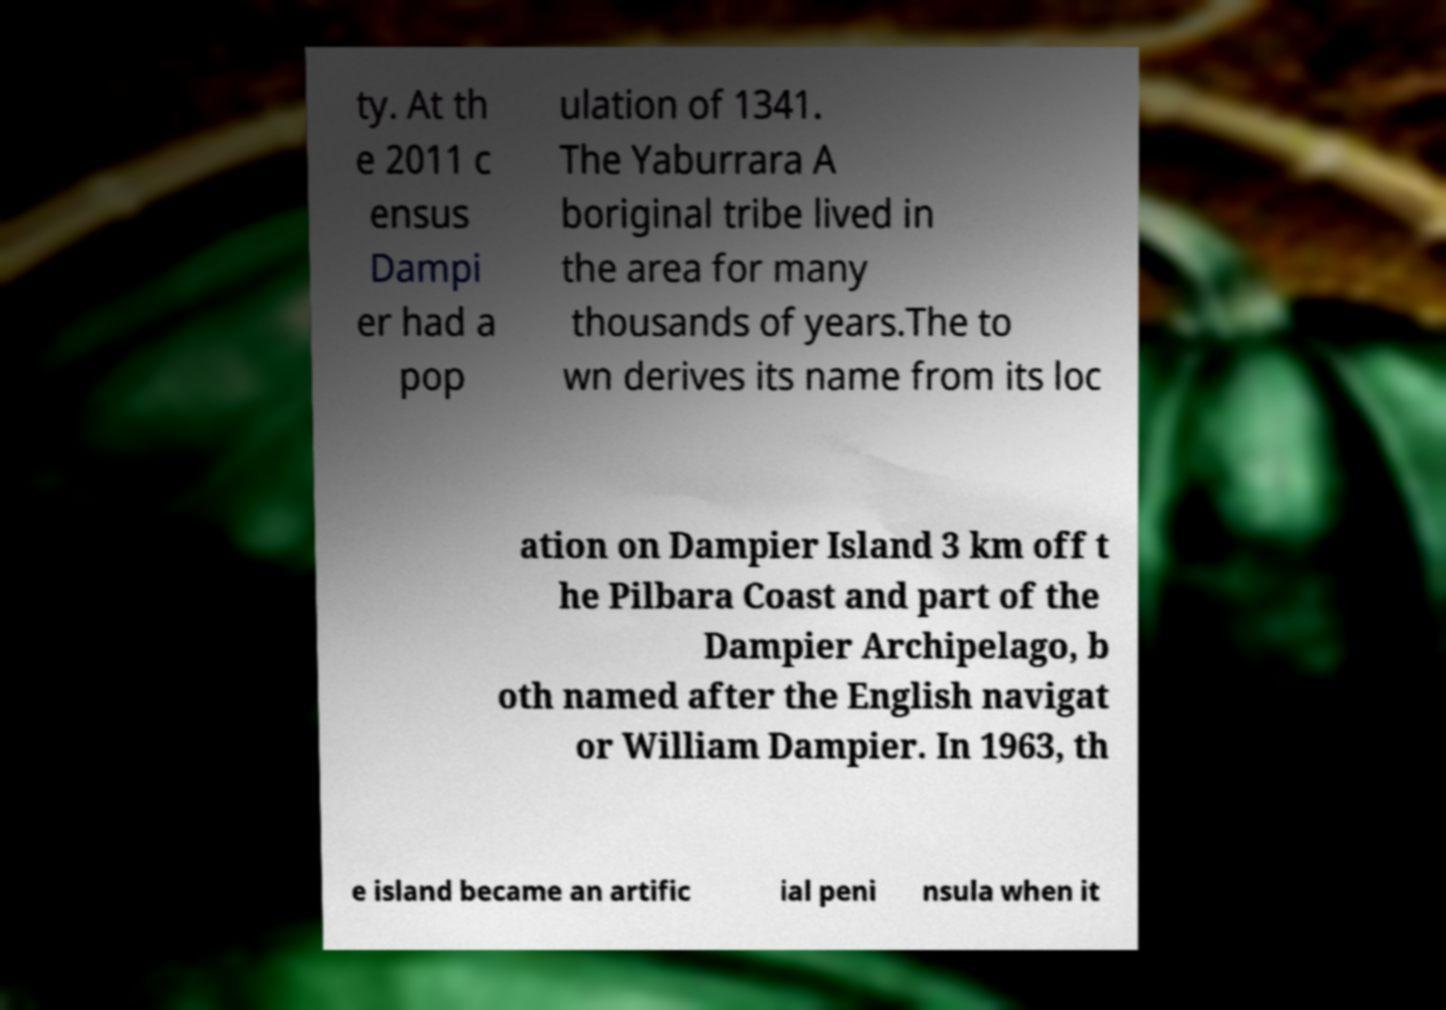Could you assist in decoding the text presented in this image and type it out clearly? ty. At th e 2011 c ensus Dampi er had a pop ulation of 1341. The Yaburrara A boriginal tribe lived in the area for many thousands of years.The to wn derives its name from its loc ation on Dampier Island 3 km off t he Pilbara Coast and part of the Dampier Archipelago, b oth named after the English navigat or William Dampier. In 1963, th e island became an artific ial peni nsula when it 